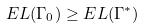<formula> <loc_0><loc_0><loc_500><loc_500>E L ( \Gamma _ { 0 } ) \geq E L ( \Gamma ^ { * } )</formula> 